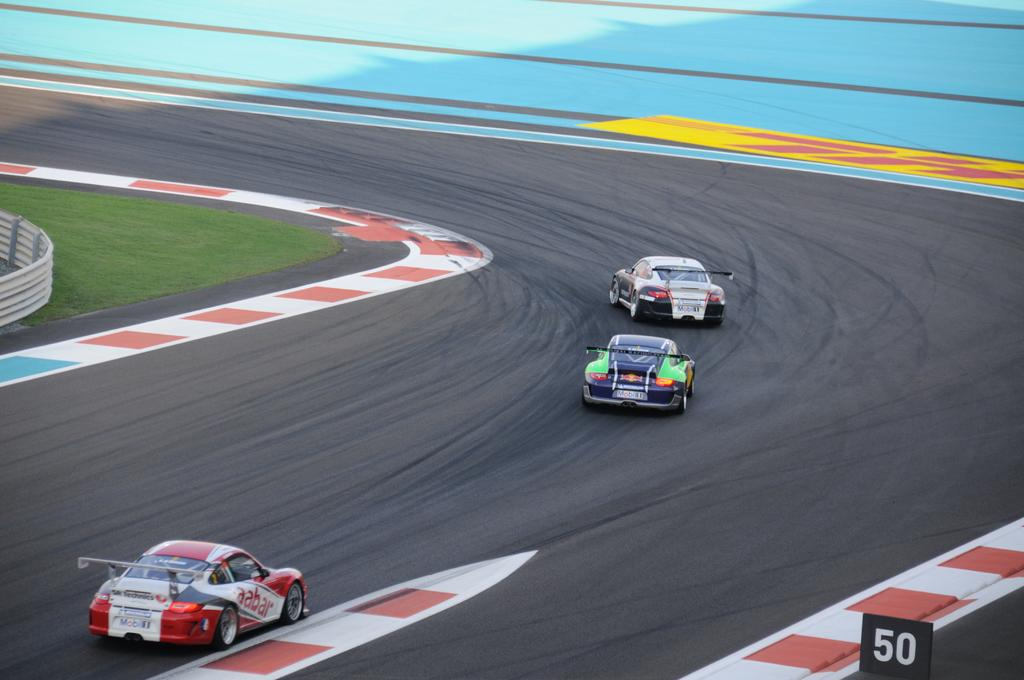How many vehicles can be seen on the road in the image? There are three vehicles on the road in the image. What can be seen in the background of the image? There is a fence, a road, and grass visible in the background of the image. What is painted on the road in the image? There is some painting on the road in the image. What type of pen is being used to write on the board in the image? There is no pen or board present in the image; it features three vehicles on the road and a background with a fence, road, grass, and painted lines. 